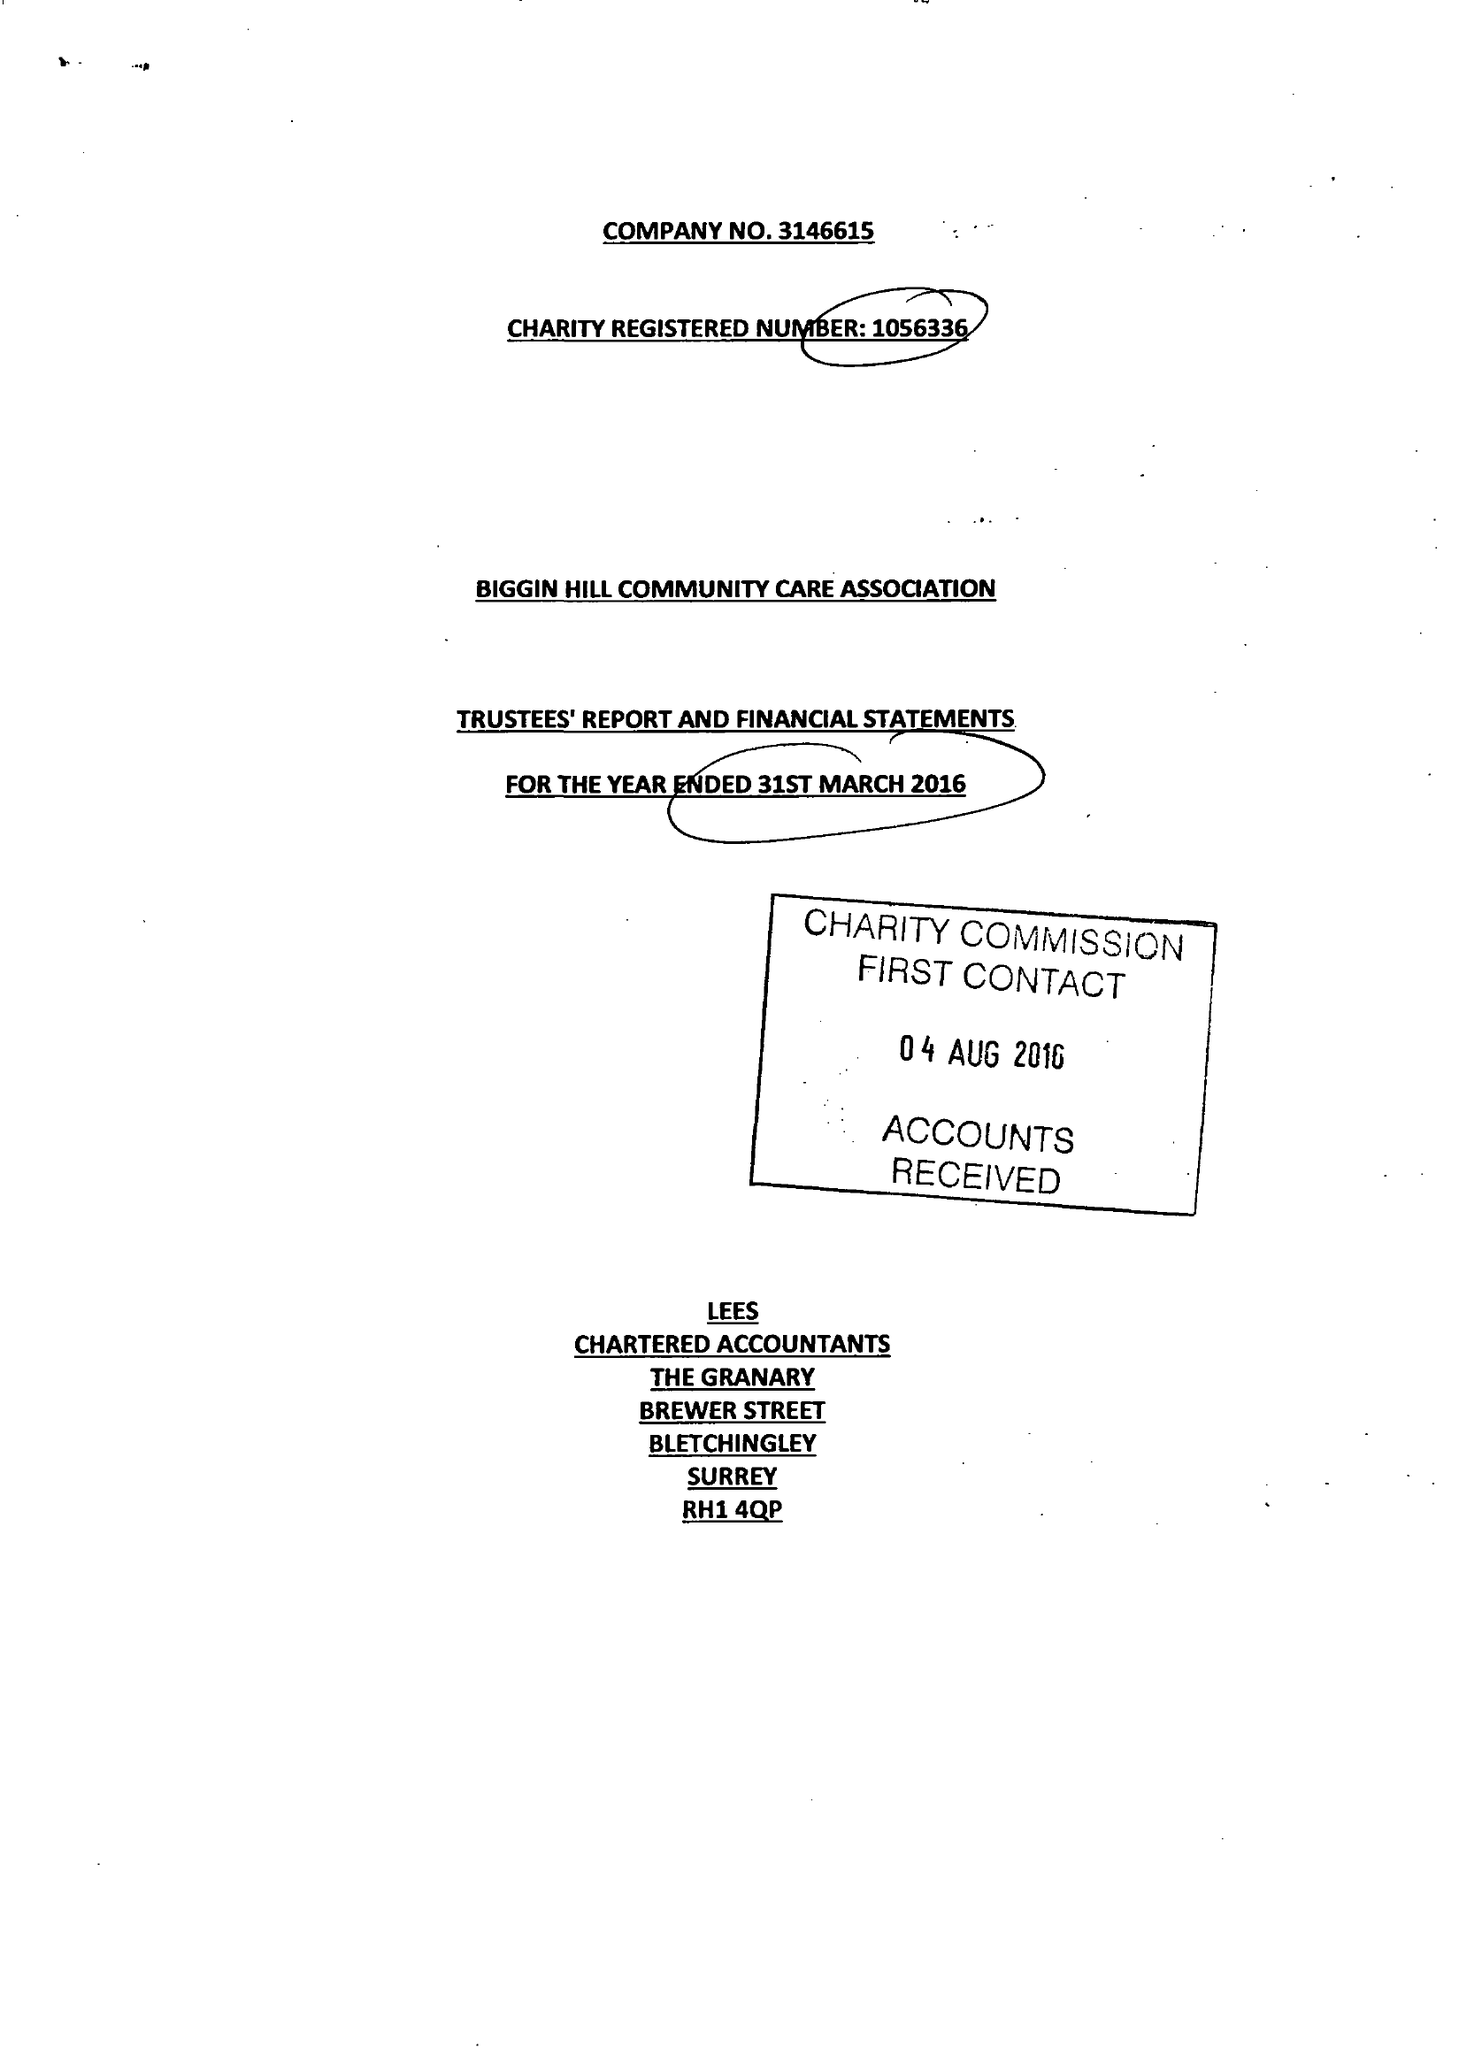What is the value for the address__street_line?
Answer the question using a single word or phrase. CHURCH ROAD 